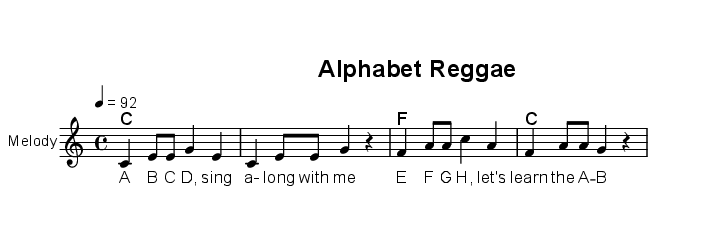What is the key signature of this music? The key signature is C major, which has no sharps or flats.
Answer: C major What is the time signature of the piece? The time signature is defined as 4/4, which means there are four beats in a measure, and the quarter note gets one beat.
Answer: 4/4 What is the tempo marking of this piece? The tempo marking indicates the speed of the music, set at 92 beats per minute (BPM), which is moderate.
Answer: 92 How many measures are there in the melody? By counting the individual musical sections in the melody, there are four complete measures shown in the provided music.
Answer: 4 What note is played at the beginning of this melody? The melody starts with the note C, as indicated by the first note in the relative pitch notation.
Answer: C Which chord is played in the first measure? The first measure is marked with the chord C major, as indicated by the chord above the staff in the music sheet.
Answer: C What musical style characterizes the structure of this piece? The piece is characterized by reggae influences, typically found in its syncopated rhythms and upbeat feel, evident in both the melody and lyrics.
Answer: Reggae 